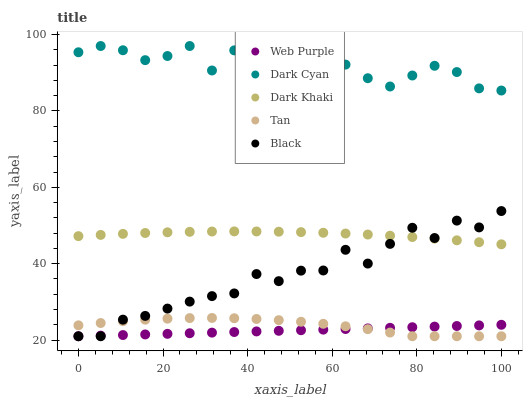Does Web Purple have the minimum area under the curve?
Answer yes or no. Yes. Does Dark Cyan have the maximum area under the curve?
Answer yes or no. Yes. Does Dark Khaki have the minimum area under the curve?
Answer yes or no. No. Does Dark Khaki have the maximum area under the curve?
Answer yes or no. No. Is Web Purple the smoothest?
Answer yes or no. Yes. Is Black the roughest?
Answer yes or no. Yes. Is Dark Khaki the smoothest?
Answer yes or no. No. Is Dark Khaki the roughest?
Answer yes or no. No. Does Web Purple have the lowest value?
Answer yes or no. Yes. Does Dark Khaki have the lowest value?
Answer yes or no. No. Does Dark Cyan have the highest value?
Answer yes or no. Yes. Does Dark Khaki have the highest value?
Answer yes or no. No. Is Web Purple less than Dark Cyan?
Answer yes or no. Yes. Is Dark Cyan greater than Black?
Answer yes or no. Yes. Does Web Purple intersect Black?
Answer yes or no. Yes. Is Web Purple less than Black?
Answer yes or no. No. Is Web Purple greater than Black?
Answer yes or no. No. Does Web Purple intersect Dark Cyan?
Answer yes or no. No. 